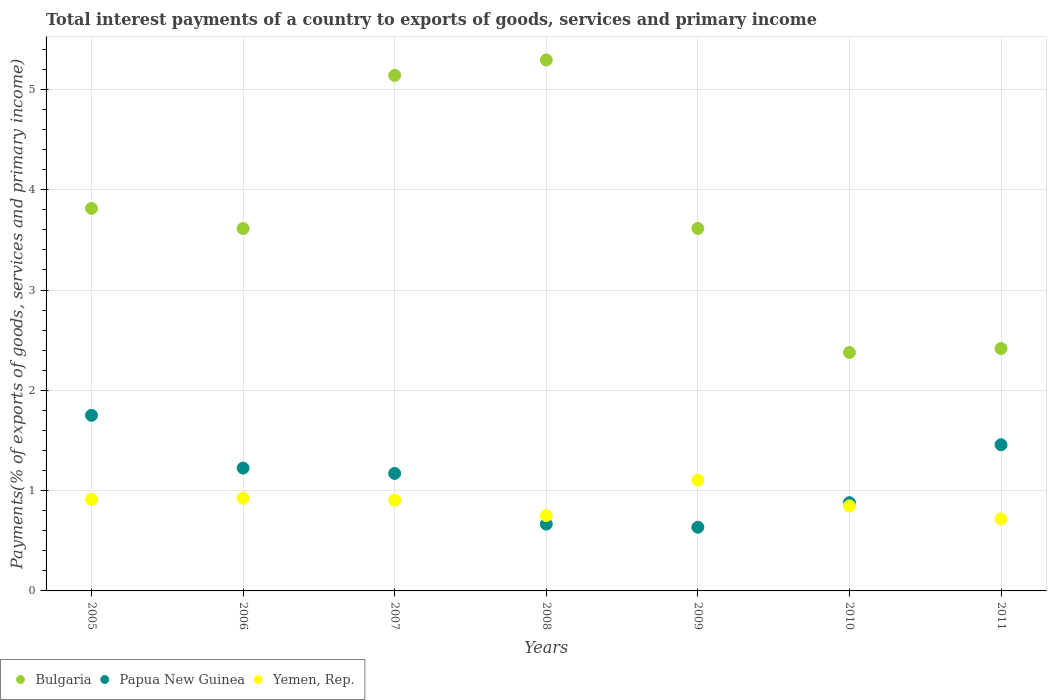How many different coloured dotlines are there?
Provide a short and direct response. 3. Is the number of dotlines equal to the number of legend labels?
Offer a very short reply. Yes. What is the total interest payments in Yemen, Rep. in 2008?
Your answer should be very brief. 0.75. Across all years, what is the maximum total interest payments in Papua New Guinea?
Your answer should be compact. 1.75. Across all years, what is the minimum total interest payments in Papua New Guinea?
Your answer should be compact. 0.64. In which year was the total interest payments in Bulgaria maximum?
Provide a short and direct response. 2008. What is the total total interest payments in Bulgaria in the graph?
Your answer should be very brief. 26.27. What is the difference between the total interest payments in Bulgaria in 2005 and that in 2006?
Your response must be concise. 0.2. What is the difference between the total interest payments in Yemen, Rep. in 2011 and the total interest payments in Papua New Guinea in 2010?
Your answer should be very brief. -0.16. What is the average total interest payments in Papua New Guinea per year?
Ensure brevity in your answer.  1.11. In the year 2011, what is the difference between the total interest payments in Bulgaria and total interest payments in Yemen, Rep.?
Your answer should be very brief. 1.7. What is the ratio of the total interest payments in Papua New Guinea in 2005 to that in 2009?
Offer a terse response. 2.76. Is the total interest payments in Yemen, Rep. in 2007 less than that in 2011?
Offer a terse response. No. Is the difference between the total interest payments in Bulgaria in 2005 and 2009 greater than the difference between the total interest payments in Yemen, Rep. in 2005 and 2009?
Make the answer very short. Yes. What is the difference between the highest and the second highest total interest payments in Papua New Guinea?
Your response must be concise. 0.29. What is the difference between the highest and the lowest total interest payments in Papua New Guinea?
Make the answer very short. 1.12. Is the sum of the total interest payments in Papua New Guinea in 2008 and 2009 greater than the maximum total interest payments in Bulgaria across all years?
Give a very brief answer. No. Does the total interest payments in Papua New Guinea monotonically increase over the years?
Provide a succinct answer. No. Is the total interest payments in Yemen, Rep. strictly greater than the total interest payments in Papua New Guinea over the years?
Provide a short and direct response. No. Is the total interest payments in Yemen, Rep. strictly less than the total interest payments in Bulgaria over the years?
Your response must be concise. Yes. How many years are there in the graph?
Provide a short and direct response. 7. What is the title of the graph?
Provide a succinct answer. Total interest payments of a country to exports of goods, services and primary income. Does "Togo" appear as one of the legend labels in the graph?
Keep it short and to the point. No. What is the label or title of the X-axis?
Keep it short and to the point. Years. What is the label or title of the Y-axis?
Keep it short and to the point. Payments(% of exports of goods, services and primary income). What is the Payments(% of exports of goods, services and primary income) in Bulgaria in 2005?
Provide a short and direct response. 3.81. What is the Payments(% of exports of goods, services and primary income) in Papua New Guinea in 2005?
Keep it short and to the point. 1.75. What is the Payments(% of exports of goods, services and primary income) of Yemen, Rep. in 2005?
Offer a terse response. 0.91. What is the Payments(% of exports of goods, services and primary income) in Bulgaria in 2006?
Give a very brief answer. 3.61. What is the Payments(% of exports of goods, services and primary income) in Papua New Guinea in 2006?
Ensure brevity in your answer.  1.22. What is the Payments(% of exports of goods, services and primary income) of Yemen, Rep. in 2006?
Offer a terse response. 0.92. What is the Payments(% of exports of goods, services and primary income) in Bulgaria in 2007?
Your answer should be compact. 5.14. What is the Payments(% of exports of goods, services and primary income) of Papua New Guinea in 2007?
Make the answer very short. 1.17. What is the Payments(% of exports of goods, services and primary income) in Yemen, Rep. in 2007?
Provide a short and direct response. 0.9. What is the Payments(% of exports of goods, services and primary income) in Bulgaria in 2008?
Provide a succinct answer. 5.29. What is the Payments(% of exports of goods, services and primary income) of Papua New Guinea in 2008?
Keep it short and to the point. 0.67. What is the Payments(% of exports of goods, services and primary income) in Yemen, Rep. in 2008?
Your answer should be compact. 0.75. What is the Payments(% of exports of goods, services and primary income) in Bulgaria in 2009?
Your answer should be very brief. 3.61. What is the Payments(% of exports of goods, services and primary income) in Papua New Guinea in 2009?
Offer a terse response. 0.64. What is the Payments(% of exports of goods, services and primary income) of Yemen, Rep. in 2009?
Provide a short and direct response. 1.1. What is the Payments(% of exports of goods, services and primary income) of Bulgaria in 2010?
Your response must be concise. 2.38. What is the Payments(% of exports of goods, services and primary income) of Papua New Guinea in 2010?
Keep it short and to the point. 0.88. What is the Payments(% of exports of goods, services and primary income) in Yemen, Rep. in 2010?
Keep it short and to the point. 0.85. What is the Payments(% of exports of goods, services and primary income) of Bulgaria in 2011?
Your answer should be compact. 2.42. What is the Payments(% of exports of goods, services and primary income) in Papua New Guinea in 2011?
Your answer should be very brief. 1.46. What is the Payments(% of exports of goods, services and primary income) of Yemen, Rep. in 2011?
Your answer should be compact. 0.72. Across all years, what is the maximum Payments(% of exports of goods, services and primary income) of Bulgaria?
Your response must be concise. 5.29. Across all years, what is the maximum Payments(% of exports of goods, services and primary income) of Papua New Guinea?
Give a very brief answer. 1.75. Across all years, what is the maximum Payments(% of exports of goods, services and primary income) in Yemen, Rep.?
Offer a very short reply. 1.1. Across all years, what is the minimum Payments(% of exports of goods, services and primary income) in Bulgaria?
Your answer should be compact. 2.38. Across all years, what is the minimum Payments(% of exports of goods, services and primary income) of Papua New Guinea?
Ensure brevity in your answer.  0.64. Across all years, what is the minimum Payments(% of exports of goods, services and primary income) of Yemen, Rep.?
Your answer should be very brief. 0.72. What is the total Payments(% of exports of goods, services and primary income) in Bulgaria in the graph?
Provide a succinct answer. 26.27. What is the total Payments(% of exports of goods, services and primary income) of Papua New Guinea in the graph?
Give a very brief answer. 7.79. What is the total Payments(% of exports of goods, services and primary income) of Yemen, Rep. in the graph?
Offer a very short reply. 6.16. What is the difference between the Payments(% of exports of goods, services and primary income) of Bulgaria in 2005 and that in 2006?
Provide a short and direct response. 0.2. What is the difference between the Payments(% of exports of goods, services and primary income) in Papua New Guinea in 2005 and that in 2006?
Offer a terse response. 0.53. What is the difference between the Payments(% of exports of goods, services and primary income) of Yemen, Rep. in 2005 and that in 2006?
Give a very brief answer. -0.01. What is the difference between the Payments(% of exports of goods, services and primary income) in Bulgaria in 2005 and that in 2007?
Make the answer very short. -1.33. What is the difference between the Payments(% of exports of goods, services and primary income) of Papua New Guinea in 2005 and that in 2007?
Keep it short and to the point. 0.58. What is the difference between the Payments(% of exports of goods, services and primary income) in Yemen, Rep. in 2005 and that in 2007?
Your answer should be compact. 0.01. What is the difference between the Payments(% of exports of goods, services and primary income) of Bulgaria in 2005 and that in 2008?
Offer a very short reply. -1.48. What is the difference between the Payments(% of exports of goods, services and primary income) in Papua New Guinea in 2005 and that in 2008?
Offer a terse response. 1.08. What is the difference between the Payments(% of exports of goods, services and primary income) in Yemen, Rep. in 2005 and that in 2008?
Keep it short and to the point. 0.16. What is the difference between the Payments(% of exports of goods, services and primary income) in Bulgaria in 2005 and that in 2009?
Provide a short and direct response. 0.2. What is the difference between the Payments(% of exports of goods, services and primary income) of Papua New Guinea in 2005 and that in 2009?
Ensure brevity in your answer.  1.12. What is the difference between the Payments(% of exports of goods, services and primary income) in Yemen, Rep. in 2005 and that in 2009?
Offer a very short reply. -0.19. What is the difference between the Payments(% of exports of goods, services and primary income) of Bulgaria in 2005 and that in 2010?
Offer a terse response. 1.44. What is the difference between the Payments(% of exports of goods, services and primary income) of Papua New Guinea in 2005 and that in 2010?
Keep it short and to the point. 0.87. What is the difference between the Payments(% of exports of goods, services and primary income) of Yemen, Rep. in 2005 and that in 2010?
Ensure brevity in your answer.  0.07. What is the difference between the Payments(% of exports of goods, services and primary income) of Bulgaria in 2005 and that in 2011?
Keep it short and to the point. 1.4. What is the difference between the Payments(% of exports of goods, services and primary income) in Papua New Guinea in 2005 and that in 2011?
Offer a very short reply. 0.29. What is the difference between the Payments(% of exports of goods, services and primary income) in Yemen, Rep. in 2005 and that in 2011?
Your answer should be compact. 0.2. What is the difference between the Payments(% of exports of goods, services and primary income) in Bulgaria in 2006 and that in 2007?
Offer a terse response. -1.53. What is the difference between the Payments(% of exports of goods, services and primary income) of Papua New Guinea in 2006 and that in 2007?
Your answer should be very brief. 0.05. What is the difference between the Payments(% of exports of goods, services and primary income) in Yemen, Rep. in 2006 and that in 2007?
Make the answer very short. 0.02. What is the difference between the Payments(% of exports of goods, services and primary income) in Bulgaria in 2006 and that in 2008?
Your answer should be very brief. -1.68. What is the difference between the Payments(% of exports of goods, services and primary income) of Papua New Guinea in 2006 and that in 2008?
Keep it short and to the point. 0.56. What is the difference between the Payments(% of exports of goods, services and primary income) of Yemen, Rep. in 2006 and that in 2008?
Your response must be concise. 0.17. What is the difference between the Payments(% of exports of goods, services and primary income) of Bulgaria in 2006 and that in 2009?
Provide a short and direct response. -0. What is the difference between the Payments(% of exports of goods, services and primary income) in Papua New Guinea in 2006 and that in 2009?
Ensure brevity in your answer.  0.59. What is the difference between the Payments(% of exports of goods, services and primary income) in Yemen, Rep. in 2006 and that in 2009?
Provide a succinct answer. -0.18. What is the difference between the Payments(% of exports of goods, services and primary income) of Bulgaria in 2006 and that in 2010?
Keep it short and to the point. 1.24. What is the difference between the Payments(% of exports of goods, services and primary income) in Papua New Guinea in 2006 and that in 2010?
Your answer should be compact. 0.34. What is the difference between the Payments(% of exports of goods, services and primary income) in Yemen, Rep. in 2006 and that in 2010?
Ensure brevity in your answer.  0.08. What is the difference between the Payments(% of exports of goods, services and primary income) of Bulgaria in 2006 and that in 2011?
Provide a succinct answer. 1.2. What is the difference between the Payments(% of exports of goods, services and primary income) in Papua New Guinea in 2006 and that in 2011?
Your answer should be very brief. -0.23. What is the difference between the Payments(% of exports of goods, services and primary income) of Yemen, Rep. in 2006 and that in 2011?
Give a very brief answer. 0.21. What is the difference between the Payments(% of exports of goods, services and primary income) of Bulgaria in 2007 and that in 2008?
Offer a very short reply. -0.15. What is the difference between the Payments(% of exports of goods, services and primary income) of Papua New Guinea in 2007 and that in 2008?
Your response must be concise. 0.51. What is the difference between the Payments(% of exports of goods, services and primary income) of Yemen, Rep. in 2007 and that in 2008?
Provide a succinct answer. 0.15. What is the difference between the Payments(% of exports of goods, services and primary income) in Bulgaria in 2007 and that in 2009?
Make the answer very short. 1.53. What is the difference between the Payments(% of exports of goods, services and primary income) of Papua New Guinea in 2007 and that in 2009?
Your response must be concise. 0.54. What is the difference between the Payments(% of exports of goods, services and primary income) in Yemen, Rep. in 2007 and that in 2009?
Make the answer very short. -0.2. What is the difference between the Payments(% of exports of goods, services and primary income) of Bulgaria in 2007 and that in 2010?
Your answer should be compact. 2.76. What is the difference between the Payments(% of exports of goods, services and primary income) in Papua New Guinea in 2007 and that in 2010?
Make the answer very short. 0.29. What is the difference between the Payments(% of exports of goods, services and primary income) in Yemen, Rep. in 2007 and that in 2010?
Give a very brief answer. 0.06. What is the difference between the Payments(% of exports of goods, services and primary income) of Bulgaria in 2007 and that in 2011?
Your answer should be very brief. 2.72. What is the difference between the Payments(% of exports of goods, services and primary income) of Papua New Guinea in 2007 and that in 2011?
Provide a short and direct response. -0.29. What is the difference between the Payments(% of exports of goods, services and primary income) of Yemen, Rep. in 2007 and that in 2011?
Offer a very short reply. 0.19. What is the difference between the Payments(% of exports of goods, services and primary income) of Bulgaria in 2008 and that in 2009?
Provide a short and direct response. 1.68. What is the difference between the Payments(% of exports of goods, services and primary income) in Papua New Guinea in 2008 and that in 2009?
Keep it short and to the point. 0.03. What is the difference between the Payments(% of exports of goods, services and primary income) in Yemen, Rep. in 2008 and that in 2009?
Offer a very short reply. -0.35. What is the difference between the Payments(% of exports of goods, services and primary income) in Bulgaria in 2008 and that in 2010?
Your answer should be compact. 2.92. What is the difference between the Payments(% of exports of goods, services and primary income) of Papua New Guinea in 2008 and that in 2010?
Your answer should be very brief. -0.21. What is the difference between the Payments(% of exports of goods, services and primary income) in Yemen, Rep. in 2008 and that in 2010?
Keep it short and to the point. -0.1. What is the difference between the Payments(% of exports of goods, services and primary income) of Bulgaria in 2008 and that in 2011?
Your answer should be compact. 2.88. What is the difference between the Payments(% of exports of goods, services and primary income) in Papua New Guinea in 2008 and that in 2011?
Provide a short and direct response. -0.79. What is the difference between the Payments(% of exports of goods, services and primary income) in Bulgaria in 2009 and that in 2010?
Provide a succinct answer. 1.24. What is the difference between the Payments(% of exports of goods, services and primary income) in Papua New Guinea in 2009 and that in 2010?
Your answer should be compact. -0.25. What is the difference between the Payments(% of exports of goods, services and primary income) in Yemen, Rep. in 2009 and that in 2010?
Make the answer very short. 0.26. What is the difference between the Payments(% of exports of goods, services and primary income) in Bulgaria in 2009 and that in 2011?
Your response must be concise. 1.2. What is the difference between the Payments(% of exports of goods, services and primary income) of Papua New Guinea in 2009 and that in 2011?
Ensure brevity in your answer.  -0.82. What is the difference between the Payments(% of exports of goods, services and primary income) of Yemen, Rep. in 2009 and that in 2011?
Offer a terse response. 0.39. What is the difference between the Payments(% of exports of goods, services and primary income) in Bulgaria in 2010 and that in 2011?
Your answer should be very brief. -0.04. What is the difference between the Payments(% of exports of goods, services and primary income) of Papua New Guinea in 2010 and that in 2011?
Keep it short and to the point. -0.58. What is the difference between the Payments(% of exports of goods, services and primary income) in Yemen, Rep. in 2010 and that in 2011?
Your answer should be very brief. 0.13. What is the difference between the Payments(% of exports of goods, services and primary income) in Bulgaria in 2005 and the Payments(% of exports of goods, services and primary income) in Papua New Guinea in 2006?
Keep it short and to the point. 2.59. What is the difference between the Payments(% of exports of goods, services and primary income) in Bulgaria in 2005 and the Payments(% of exports of goods, services and primary income) in Yemen, Rep. in 2006?
Provide a succinct answer. 2.89. What is the difference between the Payments(% of exports of goods, services and primary income) in Papua New Guinea in 2005 and the Payments(% of exports of goods, services and primary income) in Yemen, Rep. in 2006?
Provide a short and direct response. 0.83. What is the difference between the Payments(% of exports of goods, services and primary income) in Bulgaria in 2005 and the Payments(% of exports of goods, services and primary income) in Papua New Guinea in 2007?
Provide a succinct answer. 2.64. What is the difference between the Payments(% of exports of goods, services and primary income) in Bulgaria in 2005 and the Payments(% of exports of goods, services and primary income) in Yemen, Rep. in 2007?
Ensure brevity in your answer.  2.91. What is the difference between the Payments(% of exports of goods, services and primary income) in Papua New Guinea in 2005 and the Payments(% of exports of goods, services and primary income) in Yemen, Rep. in 2007?
Your answer should be very brief. 0.85. What is the difference between the Payments(% of exports of goods, services and primary income) in Bulgaria in 2005 and the Payments(% of exports of goods, services and primary income) in Papua New Guinea in 2008?
Provide a short and direct response. 3.15. What is the difference between the Payments(% of exports of goods, services and primary income) of Bulgaria in 2005 and the Payments(% of exports of goods, services and primary income) of Yemen, Rep. in 2008?
Ensure brevity in your answer.  3.06. What is the difference between the Payments(% of exports of goods, services and primary income) in Papua New Guinea in 2005 and the Payments(% of exports of goods, services and primary income) in Yemen, Rep. in 2008?
Provide a short and direct response. 1. What is the difference between the Payments(% of exports of goods, services and primary income) of Bulgaria in 2005 and the Payments(% of exports of goods, services and primary income) of Papua New Guinea in 2009?
Your answer should be compact. 3.18. What is the difference between the Payments(% of exports of goods, services and primary income) of Bulgaria in 2005 and the Payments(% of exports of goods, services and primary income) of Yemen, Rep. in 2009?
Your answer should be very brief. 2.71. What is the difference between the Payments(% of exports of goods, services and primary income) in Papua New Guinea in 2005 and the Payments(% of exports of goods, services and primary income) in Yemen, Rep. in 2009?
Your answer should be compact. 0.65. What is the difference between the Payments(% of exports of goods, services and primary income) in Bulgaria in 2005 and the Payments(% of exports of goods, services and primary income) in Papua New Guinea in 2010?
Your answer should be very brief. 2.93. What is the difference between the Payments(% of exports of goods, services and primary income) in Bulgaria in 2005 and the Payments(% of exports of goods, services and primary income) in Yemen, Rep. in 2010?
Make the answer very short. 2.97. What is the difference between the Payments(% of exports of goods, services and primary income) of Papua New Guinea in 2005 and the Payments(% of exports of goods, services and primary income) of Yemen, Rep. in 2010?
Provide a short and direct response. 0.9. What is the difference between the Payments(% of exports of goods, services and primary income) of Bulgaria in 2005 and the Payments(% of exports of goods, services and primary income) of Papua New Guinea in 2011?
Offer a very short reply. 2.36. What is the difference between the Payments(% of exports of goods, services and primary income) in Bulgaria in 2005 and the Payments(% of exports of goods, services and primary income) in Yemen, Rep. in 2011?
Provide a succinct answer. 3.1. What is the difference between the Payments(% of exports of goods, services and primary income) of Papua New Guinea in 2005 and the Payments(% of exports of goods, services and primary income) of Yemen, Rep. in 2011?
Give a very brief answer. 1.03. What is the difference between the Payments(% of exports of goods, services and primary income) of Bulgaria in 2006 and the Payments(% of exports of goods, services and primary income) of Papua New Guinea in 2007?
Your answer should be compact. 2.44. What is the difference between the Payments(% of exports of goods, services and primary income) in Bulgaria in 2006 and the Payments(% of exports of goods, services and primary income) in Yemen, Rep. in 2007?
Your answer should be compact. 2.71. What is the difference between the Payments(% of exports of goods, services and primary income) of Papua New Guinea in 2006 and the Payments(% of exports of goods, services and primary income) of Yemen, Rep. in 2007?
Your answer should be compact. 0.32. What is the difference between the Payments(% of exports of goods, services and primary income) of Bulgaria in 2006 and the Payments(% of exports of goods, services and primary income) of Papua New Guinea in 2008?
Make the answer very short. 2.95. What is the difference between the Payments(% of exports of goods, services and primary income) in Bulgaria in 2006 and the Payments(% of exports of goods, services and primary income) in Yemen, Rep. in 2008?
Your answer should be compact. 2.86. What is the difference between the Payments(% of exports of goods, services and primary income) in Papua New Guinea in 2006 and the Payments(% of exports of goods, services and primary income) in Yemen, Rep. in 2008?
Give a very brief answer. 0.47. What is the difference between the Payments(% of exports of goods, services and primary income) in Bulgaria in 2006 and the Payments(% of exports of goods, services and primary income) in Papua New Guinea in 2009?
Offer a terse response. 2.98. What is the difference between the Payments(% of exports of goods, services and primary income) in Bulgaria in 2006 and the Payments(% of exports of goods, services and primary income) in Yemen, Rep. in 2009?
Ensure brevity in your answer.  2.51. What is the difference between the Payments(% of exports of goods, services and primary income) of Papua New Guinea in 2006 and the Payments(% of exports of goods, services and primary income) of Yemen, Rep. in 2009?
Your answer should be compact. 0.12. What is the difference between the Payments(% of exports of goods, services and primary income) of Bulgaria in 2006 and the Payments(% of exports of goods, services and primary income) of Papua New Guinea in 2010?
Provide a short and direct response. 2.73. What is the difference between the Payments(% of exports of goods, services and primary income) in Bulgaria in 2006 and the Payments(% of exports of goods, services and primary income) in Yemen, Rep. in 2010?
Your answer should be compact. 2.77. What is the difference between the Payments(% of exports of goods, services and primary income) of Papua New Guinea in 2006 and the Payments(% of exports of goods, services and primary income) of Yemen, Rep. in 2010?
Your answer should be compact. 0.38. What is the difference between the Payments(% of exports of goods, services and primary income) in Bulgaria in 2006 and the Payments(% of exports of goods, services and primary income) in Papua New Guinea in 2011?
Keep it short and to the point. 2.16. What is the difference between the Payments(% of exports of goods, services and primary income) in Bulgaria in 2006 and the Payments(% of exports of goods, services and primary income) in Yemen, Rep. in 2011?
Offer a very short reply. 2.9. What is the difference between the Payments(% of exports of goods, services and primary income) of Papua New Guinea in 2006 and the Payments(% of exports of goods, services and primary income) of Yemen, Rep. in 2011?
Offer a very short reply. 0.51. What is the difference between the Payments(% of exports of goods, services and primary income) of Bulgaria in 2007 and the Payments(% of exports of goods, services and primary income) of Papua New Guinea in 2008?
Your answer should be very brief. 4.47. What is the difference between the Payments(% of exports of goods, services and primary income) in Bulgaria in 2007 and the Payments(% of exports of goods, services and primary income) in Yemen, Rep. in 2008?
Your answer should be compact. 4.39. What is the difference between the Payments(% of exports of goods, services and primary income) in Papua New Guinea in 2007 and the Payments(% of exports of goods, services and primary income) in Yemen, Rep. in 2008?
Ensure brevity in your answer.  0.42. What is the difference between the Payments(% of exports of goods, services and primary income) in Bulgaria in 2007 and the Payments(% of exports of goods, services and primary income) in Papua New Guinea in 2009?
Provide a succinct answer. 4.51. What is the difference between the Payments(% of exports of goods, services and primary income) of Bulgaria in 2007 and the Payments(% of exports of goods, services and primary income) of Yemen, Rep. in 2009?
Keep it short and to the point. 4.04. What is the difference between the Payments(% of exports of goods, services and primary income) in Papua New Guinea in 2007 and the Payments(% of exports of goods, services and primary income) in Yemen, Rep. in 2009?
Make the answer very short. 0.07. What is the difference between the Payments(% of exports of goods, services and primary income) in Bulgaria in 2007 and the Payments(% of exports of goods, services and primary income) in Papua New Guinea in 2010?
Your answer should be very brief. 4.26. What is the difference between the Payments(% of exports of goods, services and primary income) in Bulgaria in 2007 and the Payments(% of exports of goods, services and primary income) in Yemen, Rep. in 2010?
Provide a short and direct response. 4.29. What is the difference between the Payments(% of exports of goods, services and primary income) of Papua New Guinea in 2007 and the Payments(% of exports of goods, services and primary income) of Yemen, Rep. in 2010?
Provide a short and direct response. 0.32. What is the difference between the Payments(% of exports of goods, services and primary income) of Bulgaria in 2007 and the Payments(% of exports of goods, services and primary income) of Papua New Guinea in 2011?
Make the answer very short. 3.68. What is the difference between the Payments(% of exports of goods, services and primary income) of Bulgaria in 2007 and the Payments(% of exports of goods, services and primary income) of Yemen, Rep. in 2011?
Provide a succinct answer. 4.42. What is the difference between the Payments(% of exports of goods, services and primary income) in Papua New Guinea in 2007 and the Payments(% of exports of goods, services and primary income) in Yemen, Rep. in 2011?
Your answer should be compact. 0.45. What is the difference between the Payments(% of exports of goods, services and primary income) in Bulgaria in 2008 and the Payments(% of exports of goods, services and primary income) in Papua New Guinea in 2009?
Provide a short and direct response. 4.66. What is the difference between the Payments(% of exports of goods, services and primary income) of Bulgaria in 2008 and the Payments(% of exports of goods, services and primary income) of Yemen, Rep. in 2009?
Provide a short and direct response. 4.19. What is the difference between the Payments(% of exports of goods, services and primary income) in Papua New Guinea in 2008 and the Payments(% of exports of goods, services and primary income) in Yemen, Rep. in 2009?
Keep it short and to the point. -0.44. What is the difference between the Payments(% of exports of goods, services and primary income) of Bulgaria in 2008 and the Payments(% of exports of goods, services and primary income) of Papua New Guinea in 2010?
Provide a short and direct response. 4.41. What is the difference between the Payments(% of exports of goods, services and primary income) of Bulgaria in 2008 and the Payments(% of exports of goods, services and primary income) of Yemen, Rep. in 2010?
Ensure brevity in your answer.  4.45. What is the difference between the Payments(% of exports of goods, services and primary income) in Papua New Guinea in 2008 and the Payments(% of exports of goods, services and primary income) in Yemen, Rep. in 2010?
Provide a succinct answer. -0.18. What is the difference between the Payments(% of exports of goods, services and primary income) of Bulgaria in 2008 and the Payments(% of exports of goods, services and primary income) of Papua New Guinea in 2011?
Your answer should be compact. 3.84. What is the difference between the Payments(% of exports of goods, services and primary income) in Bulgaria in 2008 and the Payments(% of exports of goods, services and primary income) in Yemen, Rep. in 2011?
Your response must be concise. 4.58. What is the difference between the Payments(% of exports of goods, services and primary income) of Papua New Guinea in 2008 and the Payments(% of exports of goods, services and primary income) of Yemen, Rep. in 2011?
Provide a succinct answer. -0.05. What is the difference between the Payments(% of exports of goods, services and primary income) in Bulgaria in 2009 and the Payments(% of exports of goods, services and primary income) in Papua New Guinea in 2010?
Provide a short and direct response. 2.73. What is the difference between the Payments(% of exports of goods, services and primary income) of Bulgaria in 2009 and the Payments(% of exports of goods, services and primary income) of Yemen, Rep. in 2010?
Your response must be concise. 2.77. What is the difference between the Payments(% of exports of goods, services and primary income) in Papua New Guinea in 2009 and the Payments(% of exports of goods, services and primary income) in Yemen, Rep. in 2010?
Make the answer very short. -0.21. What is the difference between the Payments(% of exports of goods, services and primary income) of Bulgaria in 2009 and the Payments(% of exports of goods, services and primary income) of Papua New Guinea in 2011?
Provide a succinct answer. 2.16. What is the difference between the Payments(% of exports of goods, services and primary income) in Bulgaria in 2009 and the Payments(% of exports of goods, services and primary income) in Yemen, Rep. in 2011?
Offer a very short reply. 2.9. What is the difference between the Payments(% of exports of goods, services and primary income) of Papua New Guinea in 2009 and the Payments(% of exports of goods, services and primary income) of Yemen, Rep. in 2011?
Give a very brief answer. -0.08. What is the difference between the Payments(% of exports of goods, services and primary income) of Bulgaria in 2010 and the Payments(% of exports of goods, services and primary income) of Papua New Guinea in 2011?
Offer a terse response. 0.92. What is the difference between the Payments(% of exports of goods, services and primary income) in Bulgaria in 2010 and the Payments(% of exports of goods, services and primary income) in Yemen, Rep. in 2011?
Provide a succinct answer. 1.66. What is the difference between the Payments(% of exports of goods, services and primary income) of Papua New Guinea in 2010 and the Payments(% of exports of goods, services and primary income) of Yemen, Rep. in 2011?
Your response must be concise. 0.16. What is the average Payments(% of exports of goods, services and primary income) of Bulgaria per year?
Your answer should be very brief. 3.75. What is the average Payments(% of exports of goods, services and primary income) in Papua New Guinea per year?
Your response must be concise. 1.11. What is the average Payments(% of exports of goods, services and primary income) of Yemen, Rep. per year?
Offer a terse response. 0.88. In the year 2005, what is the difference between the Payments(% of exports of goods, services and primary income) of Bulgaria and Payments(% of exports of goods, services and primary income) of Papua New Guinea?
Your response must be concise. 2.06. In the year 2005, what is the difference between the Payments(% of exports of goods, services and primary income) of Bulgaria and Payments(% of exports of goods, services and primary income) of Yemen, Rep.?
Keep it short and to the point. 2.9. In the year 2005, what is the difference between the Payments(% of exports of goods, services and primary income) of Papua New Guinea and Payments(% of exports of goods, services and primary income) of Yemen, Rep.?
Make the answer very short. 0.84. In the year 2006, what is the difference between the Payments(% of exports of goods, services and primary income) of Bulgaria and Payments(% of exports of goods, services and primary income) of Papua New Guinea?
Ensure brevity in your answer.  2.39. In the year 2006, what is the difference between the Payments(% of exports of goods, services and primary income) of Bulgaria and Payments(% of exports of goods, services and primary income) of Yemen, Rep.?
Your response must be concise. 2.69. In the year 2006, what is the difference between the Payments(% of exports of goods, services and primary income) of Papua New Guinea and Payments(% of exports of goods, services and primary income) of Yemen, Rep.?
Provide a succinct answer. 0.3. In the year 2007, what is the difference between the Payments(% of exports of goods, services and primary income) of Bulgaria and Payments(% of exports of goods, services and primary income) of Papua New Guinea?
Your response must be concise. 3.97. In the year 2007, what is the difference between the Payments(% of exports of goods, services and primary income) in Bulgaria and Payments(% of exports of goods, services and primary income) in Yemen, Rep.?
Ensure brevity in your answer.  4.24. In the year 2007, what is the difference between the Payments(% of exports of goods, services and primary income) of Papua New Guinea and Payments(% of exports of goods, services and primary income) of Yemen, Rep.?
Make the answer very short. 0.27. In the year 2008, what is the difference between the Payments(% of exports of goods, services and primary income) of Bulgaria and Payments(% of exports of goods, services and primary income) of Papua New Guinea?
Provide a succinct answer. 4.63. In the year 2008, what is the difference between the Payments(% of exports of goods, services and primary income) in Bulgaria and Payments(% of exports of goods, services and primary income) in Yemen, Rep.?
Your answer should be very brief. 4.54. In the year 2008, what is the difference between the Payments(% of exports of goods, services and primary income) of Papua New Guinea and Payments(% of exports of goods, services and primary income) of Yemen, Rep.?
Your answer should be compact. -0.08. In the year 2009, what is the difference between the Payments(% of exports of goods, services and primary income) in Bulgaria and Payments(% of exports of goods, services and primary income) in Papua New Guinea?
Your response must be concise. 2.98. In the year 2009, what is the difference between the Payments(% of exports of goods, services and primary income) in Bulgaria and Payments(% of exports of goods, services and primary income) in Yemen, Rep.?
Your response must be concise. 2.51. In the year 2009, what is the difference between the Payments(% of exports of goods, services and primary income) of Papua New Guinea and Payments(% of exports of goods, services and primary income) of Yemen, Rep.?
Give a very brief answer. -0.47. In the year 2010, what is the difference between the Payments(% of exports of goods, services and primary income) in Bulgaria and Payments(% of exports of goods, services and primary income) in Papua New Guinea?
Offer a terse response. 1.5. In the year 2010, what is the difference between the Payments(% of exports of goods, services and primary income) of Bulgaria and Payments(% of exports of goods, services and primary income) of Yemen, Rep.?
Offer a terse response. 1.53. In the year 2010, what is the difference between the Payments(% of exports of goods, services and primary income) in Papua New Guinea and Payments(% of exports of goods, services and primary income) in Yemen, Rep.?
Provide a short and direct response. 0.03. In the year 2011, what is the difference between the Payments(% of exports of goods, services and primary income) of Bulgaria and Payments(% of exports of goods, services and primary income) of Papua New Guinea?
Your answer should be compact. 0.96. In the year 2011, what is the difference between the Payments(% of exports of goods, services and primary income) of Bulgaria and Payments(% of exports of goods, services and primary income) of Yemen, Rep.?
Ensure brevity in your answer.  1.7. In the year 2011, what is the difference between the Payments(% of exports of goods, services and primary income) in Papua New Guinea and Payments(% of exports of goods, services and primary income) in Yemen, Rep.?
Make the answer very short. 0.74. What is the ratio of the Payments(% of exports of goods, services and primary income) of Bulgaria in 2005 to that in 2006?
Offer a very short reply. 1.06. What is the ratio of the Payments(% of exports of goods, services and primary income) in Papua New Guinea in 2005 to that in 2006?
Give a very brief answer. 1.43. What is the ratio of the Payments(% of exports of goods, services and primary income) in Bulgaria in 2005 to that in 2007?
Give a very brief answer. 0.74. What is the ratio of the Payments(% of exports of goods, services and primary income) in Papua New Guinea in 2005 to that in 2007?
Ensure brevity in your answer.  1.49. What is the ratio of the Payments(% of exports of goods, services and primary income) in Yemen, Rep. in 2005 to that in 2007?
Offer a very short reply. 1.01. What is the ratio of the Payments(% of exports of goods, services and primary income) in Bulgaria in 2005 to that in 2008?
Your response must be concise. 0.72. What is the ratio of the Payments(% of exports of goods, services and primary income) in Papua New Guinea in 2005 to that in 2008?
Keep it short and to the point. 2.63. What is the ratio of the Payments(% of exports of goods, services and primary income) in Yemen, Rep. in 2005 to that in 2008?
Provide a short and direct response. 1.22. What is the ratio of the Payments(% of exports of goods, services and primary income) of Bulgaria in 2005 to that in 2009?
Provide a succinct answer. 1.06. What is the ratio of the Payments(% of exports of goods, services and primary income) in Papua New Guinea in 2005 to that in 2009?
Offer a very short reply. 2.76. What is the ratio of the Payments(% of exports of goods, services and primary income) in Yemen, Rep. in 2005 to that in 2009?
Offer a very short reply. 0.83. What is the ratio of the Payments(% of exports of goods, services and primary income) in Bulgaria in 2005 to that in 2010?
Give a very brief answer. 1.6. What is the ratio of the Payments(% of exports of goods, services and primary income) of Papua New Guinea in 2005 to that in 2010?
Make the answer very short. 1.99. What is the ratio of the Payments(% of exports of goods, services and primary income) in Yemen, Rep. in 2005 to that in 2010?
Your response must be concise. 1.08. What is the ratio of the Payments(% of exports of goods, services and primary income) in Bulgaria in 2005 to that in 2011?
Provide a succinct answer. 1.58. What is the ratio of the Payments(% of exports of goods, services and primary income) of Papua New Guinea in 2005 to that in 2011?
Provide a short and direct response. 1.2. What is the ratio of the Payments(% of exports of goods, services and primary income) in Yemen, Rep. in 2005 to that in 2011?
Your response must be concise. 1.27. What is the ratio of the Payments(% of exports of goods, services and primary income) of Bulgaria in 2006 to that in 2007?
Provide a short and direct response. 0.7. What is the ratio of the Payments(% of exports of goods, services and primary income) in Papua New Guinea in 2006 to that in 2007?
Make the answer very short. 1.05. What is the ratio of the Payments(% of exports of goods, services and primary income) of Yemen, Rep. in 2006 to that in 2007?
Your answer should be compact. 1.02. What is the ratio of the Payments(% of exports of goods, services and primary income) of Bulgaria in 2006 to that in 2008?
Offer a very short reply. 0.68. What is the ratio of the Payments(% of exports of goods, services and primary income) in Papua New Guinea in 2006 to that in 2008?
Ensure brevity in your answer.  1.84. What is the ratio of the Payments(% of exports of goods, services and primary income) in Yemen, Rep. in 2006 to that in 2008?
Ensure brevity in your answer.  1.23. What is the ratio of the Payments(% of exports of goods, services and primary income) of Bulgaria in 2006 to that in 2009?
Keep it short and to the point. 1. What is the ratio of the Payments(% of exports of goods, services and primary income) in Papua New Guinea in 2006 to that in 2009?
Your answer should be very brief. 1.93. What is the ratio of the Payments(% of exports of goods, services and primary income) of Yemen, Rep. in 2006 to that in 2009?
Ensure brevity in your answer.  0.84. What is the ratio of the Payments(% of exports of goods, services and primary income) in Bulgaria in 2006 to that in 2010?
Ensure brevity in your answer.  1.52. What is the ratio of the Payments(% of exports of goods, services and primary income) in Papua New Guinea in 2006 to that in 2010?
Offer a very short reply. 1.39. What is the ratio of the Payments(% of exports of goods, services and primary income) in Yemen, Rep. in 2006 to that in 2010?
Give a very brief answer. 1.09. What is the ratio of the Payments(% of exports of goods, services and primary income) in Bulgaria in 2006 to that in 2011?
Offer a terse response. 1.5. What is the ratio of the Payments(% of exports of goods, services and primary income) of Papua New Guinea in 2006 to that in 2011?
Ensure brevity in your answer.  0.84. What is the ratio of the Payments(% of exports of goods, services and primary income) of Yemen, Rep. in 2006 to that in 2011?
Ensure brevity in your answer.  1.29. What is the ratio of the Payments(% of exports of goods, services and primary income) of Bulgaria in 2007 to that in 2008?
Your answer should be compact. 0.97. What is the ratio of the Payments(% of exports of goods, services and primary income) of Papua New Guinea in 2007 to that in 2008?
Your answer should be compact. 1.76. What is the ratio of the Payments(% of exports of goods, services and primary income) in Yemen, Rep. in 2007 to that in 2008?
Ensure brevity in your answer.  1.2. What is the ratio of the Payments(% of exports of goods, services and primary income) of Bulgaria in 2007 to that in 2009?
Provide a short and direct response. 1.42. What is the ratio of the Payments(% of exports of goods, services and primary income) in Papua New Guinea in 2007 to that in 2009?
Your answer should be very brief. 1.84. What is the ratio of the Payments(% of exports of goods, services and primary income) in Yemen, Rep. in 2007 to that in 2009?
Offer a very short reply. 0.82. What is the ratio of the Payments(% of exports of goods, services and primary income) in Bulgaria in 2007 to that in 2010?
Your response must be concise. 2.16. What is the ratio of the Payments(% of exports of goods, services and primary income) of Papua New Guinea in 2007 to that in 2010?
Make the answer very short. 1.33. What is the ratio of the Payments(% of exports of goods, services and primary income) in Yemen, Rep. in 2007 to that in 2010?
Give a very brief answer. 1.07. What is the ratio of the Payments(% of exports of goods, services and primary income) of Bulgaria in 2007 to that in 2011?
Give a very brief answer. 2.13. What is the ratio of the Payments(% of exports of goods, services and primary income) of Papua New Guinea in 2007 to that in 2011?
Provide a succinct answer. 0.8. What is the ratio of the Payments(% of exports of goods, services and primary income) of Yemen, Rep. in 2007 to that in 2011?
Give a very brief answer. 1.26. What is the ratio of the Payments(% of exports of goods, services and primary income) in Bulgaria in 2008 to that in 2009?
Offer a very short reply. 1.46. What is the ratio of the Payments(% of exports of goods, services and primary income) of Papua New Guinea in 2008 to that in 2009?
Offer a very short reply. 1.05. What is the ratio of the Payments(% of exports of goods, services and primary income) of Yemen, Rep. in 2008 to that in 2009?
Ensure brevity in your answer.  0.68. What is the ratio of the Payments(% of exports of goods, services and primary income) in Bulgaria in 2008 to that in 2010?
Provide a short and direct response. 2.23. What is the ratio of the Payments(% of exports of goods, services and primary income) in Papua New Guinea in 2008 to that in 2010?
Offer a very short reply. 0.76. What is the ratio of the Payments(% of exports of goods, services and primary income) in Yemen, Rep. in 2008 to that in 2010?
Your answer should be very brief. 0.89. What is the ratio of the Payments(% of exports of goods, services and primary income) in Bulgaria in 2008 to that in 2011?
Ensure brevity in your answer.  2.19. What is the ratio of the Payments(% of exports of goods, services and primary income) in Papua New Guinea in 2008 to that in 2011?
Offer a very short reply. 0.46. What is the ratio of the Payments(% of exports of goods, services and primary income) of Yemen, Rep. in 2008 to that in 2011?
Your answer should be compact. 1.05. What is the ratio of the Payments(% of exports of goods, services and primary income) of Bulgaria in 2009 to that in 2010?
Your response must be concise. 1.52. What is the ratio of the Payments(% of exports of goods, services and primary income) in Papua New Guinea in 2009 to that in 2010?
Provide a succinct answer. 0.72. What is the ratio of the Payments(% of exports of goods, services and primary income) in Yemen, Rep. in 2009 to that in 2010?
Give a very brief answer. 1.3. What is the ratio of the Payments(% of exports of goods, services and primary income) of Bulgaria in 2009 to that in 2011?
Provide a succinct answer. 1.5. What is the ratio of the Payments(% of exports of goods, services and primary income) of Papua New Guinea in 2009 to that in 2011?
Offer a very short reply. 0.44. What is the ratio of the Payments(% of exports of goods, services and primary income) of Yemen, Rep. in 2009 to that in 2011?
Your response must be concise. 1.54. What is the ratio of the Payments(% of exports of goods, services and primary income) in Bulgaria in 2010 to that in 2011?
Provide a short and direct response. 0.98. What is the ratio of the Payments(% of exports of goods, services and primary income) in Papua New Guinea in 2010 to that in 2011?
Provide a succinct answer. 0.6. What is the ratio of the Payments(% of exports of goods, services and primary income) of Yemen, Rep. in 2010 to that in 2011?
Provide a succinct answer. 1.18. What is the difference between the highest and the second highest Payments(% of exports of goods, services and primary income) in Bulgaria?
Provide a succinct answer. 0.15. What is the difference between the highest and the second highest Payments(% of exports of goods, services and primary income) in Papua New Guinea?
Give a very brief answer. 0.29. What is the difference between the highest and the second highest Payments(% of exports of goods, services and primary income) in Yemen, Rep.?
Give a very brief answer. 0.18. What is the difference between the highest and the lowest Payments(% of exports of goods, services and primary income) in Bulgaria?
Your answer should be compact. 2.92. What is the difference between the highest and the lowest Payments(% of exports of goods, services and primary income) in Papua New Guinea?
Your answer should be very brief. 1.12. What is the difference between the highest and the lowest Payments(% of exports of goods, services and primary income) in Yemen, Rep.?
Offer a very short reply. 0.39. 